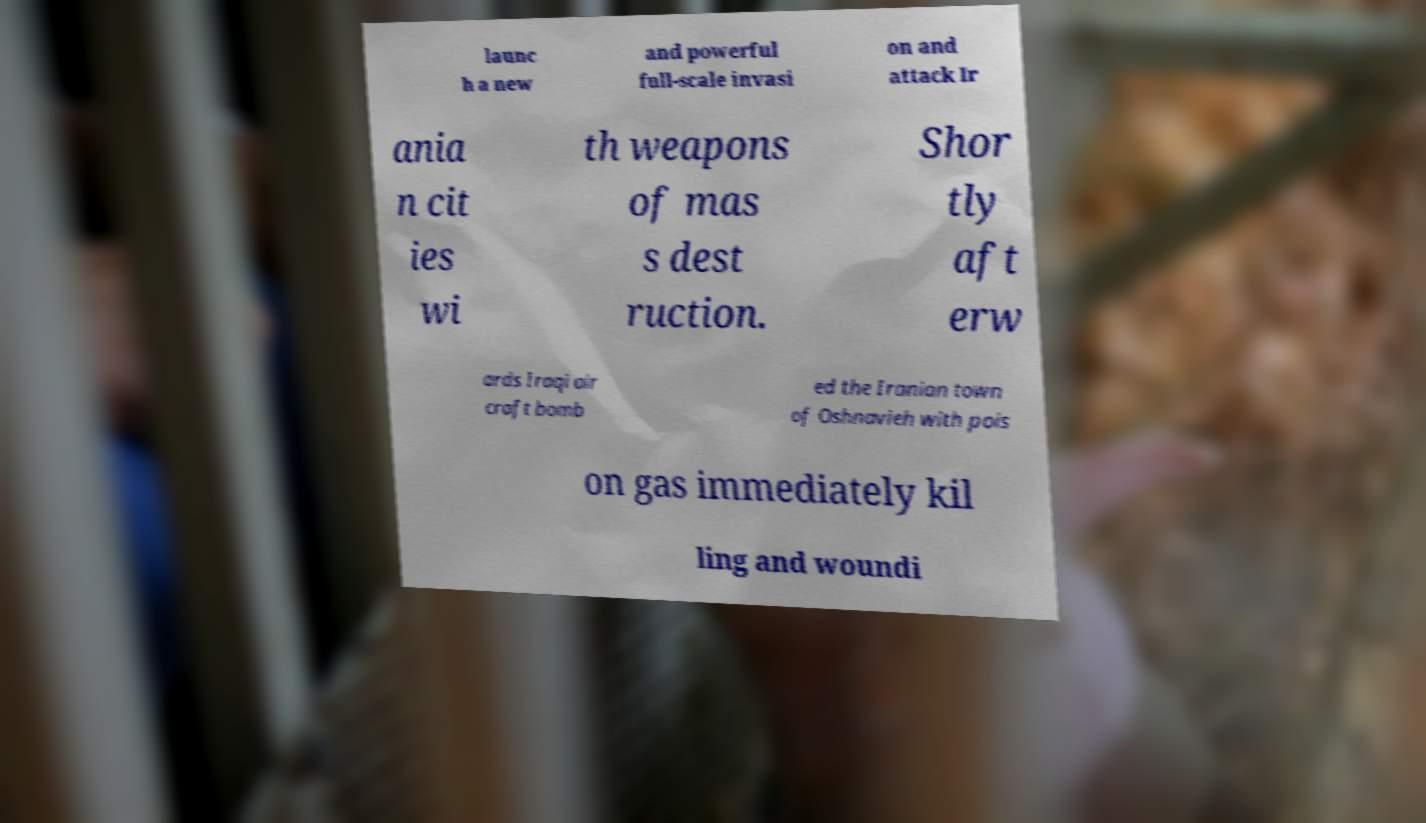I need the written content from this picture converted into text. Can you do that? launc h a new and powerful full-scale invasi on and attack Ir ania n cit ies wi th weapons of mas s dest ruction. Shor tly aft erw ards Iraqi air craft bomb ed the Iranian town of Oshnavieh with pois on gas immediately kil ling and woundi 